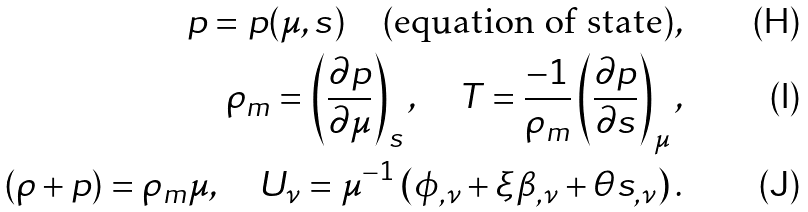<formula> <loc_0><loc_0><loc_500><loc_500>p = p ( \mu , s ) \quad \text {(equation of state)} , \\ \rho _ { m } = \left ( \frac { \partial p } { \partial \mu } \right ) _ { s } , \quad T = \frac { - 1 } { \rho _ { m } } \left ( \frac { \partial p } { \partial s } \right ) _ { \mu } , \\ ( \rho + p ) = \rho _ { m } \mu , \quad U _ { \nu } = \mu ^ { - 1 } \left ( \phi _ { , \nu } + \xi \beta _ { , \nu } + \theta s _ { , \nu } \right ) .</formula> 